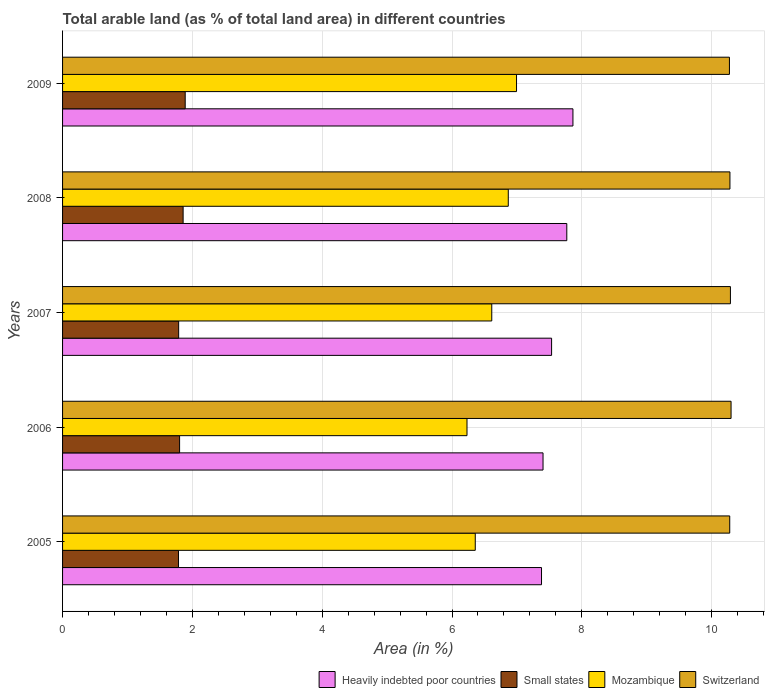How many groups of bars are there?
Your answer should be compact. 5. How many bars are there on the 1st tick from the top?
Your response must be concise. 4. What is the label of the 5th group of bars from the top?
Offer a very short reply. 2005. What is the percentage of arable land in Switzerland in 2009?
Ensure brevity in your answer.  10.27. Across all years, what is the maximum percentage of arable land in Heavily indebted poor countries?
Ensure brevity in your answer.  7.86. Across all years, what is the minimum percentage of arable land in Switzerland?
Give a very brief answer. 10.27. In which year was the percentage of arable land in Switzerland minimum?
Give a very brief answer. 2009. What is the total percentage of arable land in Mozambique in the graph?
Give a very brief answer. 33.06. What is the difference between the percentage of arable land in Switzerland in 2005 and that in 2007?
Offer a very short reply. -0.01. What is the difference between the percentage of arable land in Heavily indebted poor countries in 2009 and the percentage of arable land in Small states in 2008?
Give a very brief answer. 6.01. What is the average percentage of arable land in Mozambique per year?
Keep it short and to the point. 6.61. In the year 2005, what is the difference between the percentage of arable land in Heavily indebted poor countries and percentage of arable land in Small states?
Provide a succinct answer. 5.59. What is the ratio of the percentage of arable land in Heavily indebted poor countries in 2006 to that in 2008?
Make the answer very short. 0.95. Is the percentage of arable land in Mozambique in 2005 less than that in 2007?
Your response must be concise. Yes. What is the difference between the highest and the second highest percentage of arable land in Switzerland?
Offer a very short reply. 0.01. What is the difference between the highest and the lowest percentage of arable land in Heavily indebted poor countries?
Offer a terse response. 0.48. In how many years, is the percentage of arable land in Small states greater than the average percentage of arable land in Small states taken over all years?
Ensure brevity in your answer.  2. Is the sum of the percentage of arable land in Mozambique in 2005 and 2006 greater than the maximum percentage of arable land in Small states across all years?
Your response must be concise. Yes. Is it the case that in every year, the sum of the percentage of arable land in Mozambique and percentage of arable land in Heavily indebted poor countries is greater than the sum of percentage of arable land in Small states and percentage of arable land in Switzerland?
Make the answer very short. Yes. What does the 4th bar from the top in 2009 represents?
Ensure brevity in your answer.  Heavily indebted poor countries. What does the 4th bar from the bottom in 2007 represents?
Give a very brief answer. Switzerland. Is it the case that in every year, the sum of the percentage of arable land in Small states and percentage of arable land in Heavily indebted poor countries is greater than the percentage of arable land in Switzerland?
Offer a terse response. No. Are all the bars in the graph horizontal?
Offer a terse response. Yes. How many years are there in the graph?
Give a very brief answer. 5. Are the values on the major ticks of X-axis written in scientific E-notation?
Offer a terse response. No. Does the graph contain any zero values?
Make the answer very short. No. Does the graph contain grids?
Offer a very short reply. Yes. Where does the legend appear in the graph?
Give a very brief answer. Bottom right. How many legend labels are there?
Keep it short and to the point. 4. What is the title of the graph?
Keep it short and to the point. Total arable land (as % of total land area) in different countries. What is the label or title of the X-axis?
Ensure brevity in your answer.  Area (in %). What is the label or title of the Y-axis?
Provide a succinct answer. Years. What is the Area (in %) of Heavily indebted poor countries in 2005?
Provide a succinct answer. 7.38. What is the Area (in %) in Small states in 2005?
Make the answer very short. 1.79. What is the Area (in %) in Mozambique in 2005?
Provide a short and direct response. 6.36. What is the Area (in %) of Switzerland in 2005?
Provide a short and direct response. 10.28. What is the Area (in %) of Heavily indebted poor countries in 2006?
Keep it short and to the point. 7.4. What is the Area (in %) in Small states in 2006?
Make the answer very short. 1.8. What is the Area (in %) in Mozambique in 2006?
Provide a succinct answer. 6.23. What is the Area (in %) of Switzerland in 2006?
Your answer should be compact. 10.3. What is the Area (in %) of Heavily indebted poor countries in 2007?
Your answer should be compact. 7.53. What is the Area (in %) in Small states in 2007?
Ensure brevity in your answer.  1.79. What is the Area (in %) in Mozambique in 2007?
Make the answer very short. 6.61. What is the Area (in %) of Switzerland in 2007?
Offer a very short reply. 10.29. What is the Area (in %) in Heavily indebted poor countries in 2008?
Offer a very short reply. 7.77. What is the Area (in %) in Small states in 2008?
Your answer should be compact. 1.86. What is the Area (in %) of Mozambique in 2008?
Offer a very short reply. 6.87. What is the Area (in %) in Switzerland in 2008?
Offer a terse response. 10.28. What is the Area (in %) of Heavily indebted poor countries in 2009?
Your answer should be compact. 7.86. What is the Area (in %) in Small states in 2009?
Make the answer very short. 1.89. What is the Area (in %) in Mozambique in 2009?
Ensure brevity in your answer.  6.99. What is the Area (in %) of Switzerland in 2009?
Your answer should be very brief. 10.27. Across all years, what is the maximum Area (in %) of Heavily indebted poor countries?
Make the answer very short. 7.86. Across all years, what is the maximum Area (in %) of Small states?
Provide a succinct answer. 1.89. Across all years, what is the maximum Area (in %) in Mozambique?
Offer a terse response. 6.99. Across all years, what is the maximum Area (in %) of Switzerland?
Your answer should be very brief. 10.3. Across all years, what is the minimum Area (in %) of Heavily indebted poor countries?
Provide a short and direct response. 7.38. Across all years, what is the minimum Area (in %) of Small states?
Keep it short and to the point. 1.79. Across all years, what is the minimum Area (in %) in Mozambique?
Provide a succinct answer. 6.23. Across all years, what is the minimum Area (in %) in Switzerland?
Provide a short and direct response. 10.27. What is the total Area (in %) in Heavily indebted poor countries in the graph?
Provide a short and direct response. 37.95. What is the total Area (in %) of Small states in the graph?
Your answer should be very brief. 9.12. What is the total Area (in %) in Mozambique in the graph?
Keep it short and to the point. 33.06. What is the total Area (in %) of Switzerland in the graph?
Give a very brief answer. 51.42. What is the difference between the Area (in %) of Heavily indebted poor countries in 2005 and that in 2006?
Offer a terse response. -0.02. What is the difference between the Area (in %) of Small states in 2005 and that in 2006?
Keep it short and to the point. -0.02. What is the difference between the Area (in %) in Mozambique in 2005 and that in 2006?
Offer a terse response. 0.13. What is the difference between the Area (in %) in Switzerland in 2005 and that in 2006?
Your answer should be compact. -0.02. What is the difference between the Area (in %) of Heavily indebted poor countries in 2005 and that in 2007?
Offer a terse response. -0.16. What is the difference between the Area (in %) in Small states in 2005 and that in 2007?
Provide a short and direct response. -0. What is the difference between the Area (in %) in Mozambique in 2005 and that in 2007?
Provide a succinct answer. -0.25. What is the difference between the Area (in %) of Switzerland in 2005 and that in 2007?
Offer a very short reply. -0.01. What is the difference between the Area (in %) of Heavily indebted poor countries in 2005 and that in 2008?
Make the answer very short. -0.39. What is the difference between the Area (in %) of Small states in 2005 and that in 2008?
Your answer should be compact. -0.07. What is the difference between the Area (in %) of Mozambique in 2005 and that in 2008?
Offer a very short reply. -0.51. What is the difference between the Area (in %) in Switzerland in 2005 and that in 2008?
Provide a succinct answer. -0. What is the difference between the Area (in %) in Heavily indebted poor countries in 2005 and that in 2009?
Give a very brief answer. -0.48. What is the difference between the Area (in %) of Small states in 2005 and that in 2009?
Offer a very short reply. -0.1. What is the difference between the Area (in %) of Mozambique in 2005 and that in 2009?
Ensure brevity in your answer.  -0.64. What is the difference between the Area (in %) in Switzerland in 2005 and that in 2009?
Make the answer very short. 0. What is the difference between the Area (in %) of Heavily indebted poor countries in 2006 and that in 2007?
Your answer should be very brief. -0.13. What is the difference between the Area (in %) of Small states in 2006 and that in 2007?
Give a very brief answer. 0.01. What is the difference between the Area (in %) in Mozambique in 2006 and that in 2007?
Make the answer very short. -0.38. What is the difference between the Area (in %) of Switzerland in 2006 and that in 2007?
Give a very brief answer. 0.01. What is the difference between the Area (in %) in Heavily indebted poor countries in 2006 and that in 2008?
Your answer should be compact. -0.37. What is the difference between the Area (in %) in Small states in 2006 and that in 2008?
Give a very brief answer. -0.05. What is the difference between the Area (in %) of Mozambique in 2006 and that in 2008?
Make the answer very short. -0.64. What is the difference between the Area (in %) in Switzerland in 2006 and that in 2008?
Make the answer very short. 0.02. What is the difference between the Area (in %) of Heavily indebted poor countries in 2006 and that in 2009?
Offer a terse response. -0.46. What is the difference between the Area (in %) of Small states in 2006 and that in 2009?
Offer a terse response. -0.09. What is the difference between the Area (in %) of Mozambique in 2006 and that in 2009?
Your answer should be compact. -0.76. What is the difference between the Area (in %) in Switzerland in 2006 and that in 2009?
Offer a terse response. 0.03. What is the difference between the Area (in %) in Heavily indebted poor countries in 2007 and that in 2008?
Your answer should be compact. -0.23. What is the difference between the Area (in %) in Small states in 2007 and that in 2008?
Your response must be concise. -0.07. What is the difference between the Area (in %) in Mozambique in 2007 and that in 2008?
Your response must be concise. -0.25. What is the difference between the Area (in %) of Switzerland in 2007 and that in 2008?
Ensure brevity in your answer.  0.01. What is the difference between the Area (in %) of Heavily indebted poor countries in 2007 and that in 2009?
Provide a short and direct response. -0.33. What is the difference between the Area (in %) of Small states in 2007 and that in 2009?
Provide a succinct answer. -0.1. What is the difference between the Area (in %) of Mozambique in 2007 and that in 2009?
Your answer should be compact. -0.38. What is the difference between the Area (in %) of Switzerland in 2007 and that in 2009?
Your response must be concise. 0.02. What is the difference between the Area (in %) in Heavily indebted poor countries in 2008 and that in 2009?
Offer a terse response. -0.09. What is the difference between the Area (in %) of Small states in 2008 and that in 2009?
Ensure brevity in your answer.  -0.03. What is the difference between the Area (in %) of Mozambique in 2008 and that in 2009?
Ensure brevity in your answer.  -0.13. What is the difference between the Area (in %) in Switzerland in 2008 and that in 2009?
Provide a succinct answer. 0.01. What is the difference between the Area (in %) in Heavily indebted poor countries in 2005 and the Area (in %) in Small states in 2006?
Give a very brief answer. 5.58. What is the difference between the Area (in %) of Heavily indebted poor countries in 2005 and the Area (in %) of Mozambique in 2006?
Ensure brevity in your answer.  1.15. What is the difference between the Area (in %) of Heavily indebted poor countries in 2005 and the Area (in %) of Switzerland in 2006?
Provide a succinct answer. -2.92. What is the difference between the Area (in %) of Small states in 2005 and the Area (in %) of Mozambique in 2006?
Make the answer very short. -4.45. What is the difference between the Area (in %) of Small states in 2005 and the Area (in %) of Switzerland in 2006?
Provide a succinct answer. -8.51. What is the difference between the Area (in %) of Mozambique in 2005 and the Area (in %) of Switzerland in 2006?
Your answer should be very brief. -3.94. What is the difference between the Area (in %) of Heavily indebted poor countries in 2005 and the Area (in %) of Small states in 2007?
Make the answer very short. 5.59. What is the difference between the Area (in %) of Heavily indebted poor countries in 2005 and the Area (in %) of Mozambique in 2007?
Provide a succinct answer. 0.77. What is the difference between the Area (in %) in Heavily indebted poor countries in 2005 and the Area (in %) in Switzerland in 2007?
Your answer should be compact. -2.91. What is the difference between the Area (in %) in Small states in 2005 and the Area (in %) in Mozambique in 2007?
Provide a short and direct response. -4.83. What is the difference between the Area (in %) in Small states in 2005 and the Area (in %) in Switzerland in 2007?
Make the answer very short. -8.5. What is the difference between the Area (in %) in Mozambique in 2005 and the Area (in %) in Switzerland in 2007?
Make the answer very short. -3.93. What is the difference between the Area (in %) of Heavily indebted poor countries in 2005 and the Area (in %) of Small states in 2008?
Your answer should be very brief. 5.52. What is the difference between the Area (in %) in Heavily indebted poor countries in 2005 and the Area (in %) in Mozambique in 2008?
Provide a short and direct response. 0.51. What is the difference between the Area (in %) of Heavily indebted poor countries in 2005 and the Area (in %) of Switzerland in 2008?
Provide a succinct answer. -2.9. What is the difference between the Area (in %) of Small states in 2005 and the Area (in %) of Mozambique in 2008?
Keep it short and to the point. -5.08. What is the difference between the Area (in %) of Small states in 2005 and the Area (in %) of Switzerland in 2008?
Provide a short and direct response. -8.5. What is the difference between the Area (in %) of Mozambique in 2005 and the Area (in %) of Switzerland in 2008?
Provide a succinct answer. -3.92. What is the difference between the Area (in %) in Heavily indebted poor countries in 2005 and the Area (in %) in Small states in 2009?
Give a very brief answer. 5.49. What is the difference between the Area (in %) in Heavily indebted poor countries in 2005 and the Area (in %) in Mozambique in 2009?
Give a very brief answer. 0.39. What is the difference between the Area (in %) of Heavily indebted poor countries in 2005 and the Area (in %) of Switzerland in 2009?
Make the answer very short. -2.9. What is the difference between the Area (in %) in Small states in 2005 and the Area (in %) in Mozambique in 2009?
Your answer should be compact. -5.21. What is the difference between the Area (in %) in Small states in 2005 and the Area (in %) in Switzerland in 2009?
Your answer should be compact. -8.49. What is the difference between the Area (in %) of Mozambique in 2005 and the Area (in %) of Switzerland in 2009?
Give a very brief answer. -3.92. What is the difference between the Area (in %) of Heavily indebted poor countries in 2006 and the Area (in %) of Small states in 2007?
Provide a short and direct response. 5.61. What is the difference between the Area (in %) of Heavily indebted poor countries in 2006 and the Area (in %) of Mozambique in 2007?
Make the answer very short. 0.79. What is the difference between the Area (in %) in Heavily indebted poor countries in 2006 and the Area (in %) in Switzerland in 2007?
Give a very brief answer. -2.89. What is the difference between the Area (in %) of Small states in 2006 and the Area (in %) of Mozambique in 2007?
Offer a terse response. -4.81. What is the difference between the Area (in %) of Small states in 2006 and the Area (in %) of Switzerland in 2007?
Make the answer very short. -8.49. What is the difference between the Area (in %) in Mozambique in 2006 and the Area (in %) in Switzerland in 2007?
Provide a short and direct response. -4.06. What is the difference between the Area (in %) in Heavily indebted poor countries in 2006 and the Area (in %) in Small states in 2008?
Provide a short and direct response. 5.55. What is the difference between the Area (in %) of Heavily indebted poor countries in 2006 and the Area (in %) of Mozambique in 2008?
Your answer should be compact. 0.54. What is the difference between the Area (in %) in Heavily indebted poor countries in 2006 and the Area (in %) in Switzerland in 2008?
Ensure brevity in your answer.  -2.88. What is the difference between the Area (in %) in Small states in 2006 and the Area (in %) in Mozambique in 2008?
Make the answer very short. -5.06. What is the difference between the Area (in %) of Small states in 2006 and the Area (in %) of Switzerland in 2008?
Keep it short and to the point. -8.48. What is the difference between the Area (in %) of Mozambique in 2006 and the Area (in %) of Switzerland in 2008?
Your answer should be compact. -4.05. What is the difference between the Area (in %) of Heavily indebted poor countries in 2006 and the Area (in %) of Small states in 2009?
Provide a short and direct response. 5.51. What is the difference between the Area (in %) of Heavily indebted poor countries in 2006 and the Area (in %) of Mozambique in 2009?
Give a very brief answer. 0.41. What is the difference between the Area (in %) of Heavily indebted poor countries in 2006 and the Area (in %) of Switzerland in 2009?
Offer a very short reply. -2.87. What is the difference between the Area (in %) in Small states in 2006 and the Area (in %) in Mozambique in 2009?
Your answer should be very brief. -5.19. What is the difference between the Area (in %) in Small states in 2006 and the Area (in %) in Switzerland in 2009?
Your response must be concise. -8.47. What is the difference between the Area (in %) in Mozambique in 2006 and the Area (in %) in Switzerland in 2009?
Your answer should be very brief. -4.04. What is the difference between the Area (in %) of Heavily indebted poor countries in 2007 and the Area (in %) of Small states in 2008?
Give a very brief answer. 5.68. What is the difference between the Area (in %) in Heavily indebted poor countries in 2007 and the Area (in %) in Mozambique in 2008?
Your answer should be compact. 0.67. What is the difference between the Area (in %) of Heavily indebted poor countries in 2007 and the Area (in %) of Switzerland in 2008?
Ensure brevity in your answer.  -2.75. What is the difference between the Area (in %) of Small states in 2007 and the Area (in %) of Mozambique in 2008?
Give a very brief answer. -5.08. What is the difference between the Area (in %) in Small states in 2007 and the Area (in %) in Switzerland in 2008?
Your response must be concise. -8.49. What is the difference between the Area (in %) of Mozambique in 2007 and the Area (in %) of Switzerland in 2008?
Offer a terse response. -3.67. What is the difference between the Area (in %) in Heavily indebted poor countries in 2007 and the Area (in %) in Small states in 2009?
Your answer should be compact. 5.64. What is the difference between the Area (in %) in Heavily indebted poor countries in 2007 and the Area (in %) in Mozambique in 2009?
Ensure brevity in your answer.  0.54. What is the difference between the Area (in %) in Heavily indebted poor countries in 2007 and the Area (in %) in Switzerland in 2009?
Make the answer very short. -2.74. What is the difference between the Area (in %) of Small states in 2007 and the Area (in %) of Mozambique in 2009?
Keep it short and to the point. -5.21. What is the difference between the Area (in %) in Small states in 2007 and the Area (in %) in Switzerland in 2009?
Provide a short and direct response. -8.49. What is the difference between the Area (in %) in Mozambique in 2007 and the Area (in %) in Switzerland in 2009?
Give a very brief answer. -3.66. What is the difference between the Area (in %) in Heavily indebted poor countries in 2008 and the Area (in %) in Small states in 2009?
Your answer should be compact. 5.88. What is the difference between the Area (in %) of Heavily indebted poor countries in 2008 and the Area (in %) of Mozambique in 2009?
Give a very brief answer. 0.77. What is the difference between the Area (in %) in Heavily indebted poor countries in 2008 and the Area (in %) in Switzerland in 2009?
Your answer should be compact. -2.51. What is the difference between the Area (in %) of Small states in 2008 and the Area (in %) of Mozambique in 2009?
Offer a very short reply. -5.14. What is the difference between the Area (in %) in Small states in 2008 and the Area (in %) in Switzerland in 2009?
Provide a succinct answer. -8.42. What is the difference between the Area (in %) of Mozambique in 2008 and the Area (in %) of Switzerland in 2009?
Your answer should be compact. -3.41. What is the average Area (in %) in Heavily indebted poor countries per year?
Your answer should be very brief. 7.59. What is the average Area (in %) of Small states per year?
Provide a succinct answer. 1.82. What is the average Area (in %) of Mozambique per year?
Your answer should be very brief. 6.61. What is the average Area (in %) of Switzerland per year?
Offer a terse response. 10.28. In the year 2005, what is the difference between the Area (in %) of Heavily indebted poor countries and Area (in %) of Small states?
Give a very brief answer. 5.59. In the year 2005, what is the difference between the Area (in %) of Heavily indebted poor countries and Area (in %) of Mozambique?
Offer a terse response. 1.02. In the year 2005, what is the difference between the Area (in %) of Heavily indebted poor countries and Area (in %) of Switzerland?
Your response must be concise. -2.9. In the year 2005, what is the difference between the Area (in %) in Small states and Area (in %) in Mozambique?
Make the answer very short. -4.57. In the year 2005, what is the difference between the Area (in %) in Small states and Area (in %) in Switzerland?
Provide a succinct answer. -8.49. In the year 2005, what is the difference between the Area (in %) in Mozambique and Area (in %) in Switzerland?
Provide a short and direct response. -3.92. In the year 2006, what is the difference between the Area (in %) of Heavily indebted poor countries and Area (in %) of Small states?
Keep it short and to the point. 5.6. In the year 2006, what is the difference between the Area (in %) of Heavily indebted poor countries and Area (in %) of Mozambique?
Keep it short and to the point. 1.17. In the year 2006, what is the difference between the Area (in %) in Heavily indebted poor countries and Area (in %) in Switzerland?
Offer a very short reply. -2.9. In the year 2006, what is the difference between the Area (in %) in Small states and Area (in %) in Mozambique?
Your response must be concise. -4.43. In the year 2006, what is the difference between the Area (in %) in Small states and Area (in %) in Switzerland?
Give a very brief answer. -8.5. In the year 2006, what is the difference between the Area (in %) in Mozambique and Area (in %) in Switzerland?
Keep it short and to the point. -4.07. In the year 2007, what is the difference between the Area (in %) of Heavily indebted poor countries and Area (in %) of Small states?
Provide a succinct answer. 5.75. In the year 2007, what is the difference between the Area (in %) in Heavily indebted poor countries and Area (in %) in Mozambique?
Provide a succinct answer. 0.92. In the year 2007, what is the difference between the Area (in %) in Heavily indebted poor countries and Area (in %) in Switzerland?
Your answer should be very brief. -2.76. In the year 2007, what is the difference between the Area (in %) in Small states and Area (in %) in Mozambique?
Make the answer very short. -4.82. In the year 2007, what is the difference between the Area (in %) in Small states and Area (in %) in Switzerland?
Make the answer very short. -8.5. In the year 2007, what is the difference between the Area (in %) in Mozambique and Area (in %) in Switzerland?
Your answer should be very brief. -3.68. In the year 2008, what is the difference between the Area (in %) in Heavily indebted poor countries and Area (in %) in Small states?
Give a very brief answer. 5.91. In the year 2008, what is the difference between the Area (in %) of Heavily indebted poor countries and Area (in %) of Mozambique?
Keep it short and to the point. 0.9. In the year 2008, what is the difference between the Area (in %) of Heavily indebted poor countries and Area (in %) of Switzerland?
Give a very brief answer. -2.51. In the year 2008, what is the difference between the Area (in %) in Small states and Area (in %) in Mozambique?
Offer a terse response. -5.01. In the year 2008, what is the difference between the Area (in %) of Small states and Area (in %) of Switzerland?
Provide a succinct answer. -8.42. In the year 2008, what is the difference between the Area (in %) of Mozambique and Area (in %) of Switzerland?
Your answer should be compact. -3.42. In the year 2009, what is the difference between the Area (in %) of Heavily indebted poor countries and Area (in %) of Small states?
Offer a very short reply. 5.97. In the year 2009, what is the difference between the Area (in %) in Heavily indebted poor countries and Area (in %) in Mozambique?
Provide a succinct answer. 0.87. In the year 2009, what is the difference between the Area (in %) in Heavily indebted poor countries and Area (in %) in Switzerland?
Provide a succinct answer. -2.41. In the year 2009, what is the difference between the Area (in %) in Small states and Area (in %) in Mozambique?
Provide a succinct answer. -5.1. In the year 2009, what is the difference between the Area (in %) in Small states and Area (in %) in Switzerland?
Offer a very short reply. -8.38. In the year 2009, what is the difference between the Area (in %) of Mozambique and Area (in %) of Switzerland?
Your answer should be very brief. -3.28. What is the ratio of the Area (in %) in Small states in 2005 to that in 2006?
Your answer should be compact. 0.99. What is the ratio of the Area (in %) of Mozambique in 2005 to that in 2006?
Keep it short and to the point. 1.02. What is the ratio of the Area (in %) in Switzerland in 2005 to that in 2006?
Offer a terse response. 1. What is the ratio of the Area (in %) in Heavily indebted poor countries in 2005 to that in 2007?
Your response must be concise. 0.98. What is the ratio of the Area (in %) of Mozambique in 2005 to that in 2007?
Your answer should be compact. 0.96. What is the ratio of the Area (in %) in Heavily indebted poor countries in 2005 to that in 2008?
Offer a very short reply. 0.95. What is the ratio of the Area (in %) of Small states in 2005 to that in 2008?
Ensure brevity in your answer.  0.96. What is the ratio of the Area (in %) in Mozambique in 2005 to that in 2008?
Ensure brevity in your answer.  0.93. What is the ratio of the Area (in %) in Heavily indebted poor countries in 2005 to that in 2009?
Your answer should be compact. 0.94. What is the ratio of the Area (in %) of Small states in 2005 to that in 2009?
Keep it short and to the point. 0.95. What is the ratio of the Area (in %) of Heavily indebted poor countries in 2006 to that in 2007?
Make the answer very short. 0.98. What is the ratio of the Area (in %) in Small states in 2006 to that in 2007?
Provide a succinct answer. 1.01. What is the ratio of the Area (in %) in Mozambique in 2006 to that in 2007?
Your answer should be very brief. 0.94. What is the ratio of the Area (in %) of Switzerland in 2006 to that in 2007?
Provide a short and direct response. 1. What is the ratio of the Area (in %) in Heavily indebted poor countries in 2006 to that in 2008?
Offer a very short reply. 0.95. What is the ratio of the Area (in %) of Small states in 2006 to that in 2008?
Provide a succinct answer. 0.97. What is the ratio of the Area (in %) in Mozambique in 2006 to that in 2008?
Your answer should be compact. 0.91. What is the ratio of the Area (in %) in Heavily indebted poor countries in 2006 to that in 2009?
Provide a short and direct response. 0.94. What is the ratio of the Area (in %) of Small states in 2006 to that in 2009?
Your answer should be compact. 0.95. What is the ratio of the Area (in %) of Mozambique in 2006 to that in 2009?
Your answer should be very brief. 0.89. What is the ratio of the Area (in %) of Switzerland in 2006 to that in 2009?
Give a very brief answer. 1. What is the ratio of the Area (in %) of Heavily indebted poor countries in 2007 to that in 2008?
Your response must be concise. 0.97. What is the ratio of the Area (in %) in Small states in 2007 to that in 2008?
Offer a very short reply. 0.96. What is the ratio of the Area (in %) of Switzerland in 2007 to that in 2008?
Offer a terse response. 1. What is the ratio of the Area (in %) of Heavily indebted poor countries in 2007 to that in 2009?
Provide a short and direct response. 0.96. What is the ratio of the Area (in %) of Small states in 2007 to that in 2009?
Offer a terse response. 0.95. What is the ratio of the Area (in %) of Mozambique in 2007 to that in 2009?
Your response must be concise. 0.95. What is the ratio of the Area (in %) in Small states in 2008 to that in 2009?
Ensure brevity in your answer.  0.98. What is the ratio of the Area (in %) in Mozambique in 2008 to that in 2009?
Keep it short and to the point. 0.98. What is the ratio of the Area (in %) of Switzerland in 2008 to that in 2009?
Provide a short and direct response. 1. What is the difference between the highest and the second highest Area (in %) in Heavily indebted poor countries?
Provide a succinct answer. 0.09. What is the difference between the highest and the second highest Area (in %) in Small states?
Provide a succinct answer. 0.03. What is the difference between the highest and the second highest Area (in %) of Mozambique?
Make the answer very short. 0.13. What is the difference between the highest and the second highest Area (in %) of Switzerland?
Give a very brief answer. 0.01. What is the difference between the highest and the lowest Area (in %) of Heavily indebted poor countries?
Keep it short and to the point. 0.48. What is the difference between the highest and the lowest Area (in %) in Small states?
Offer a terse response. 0.1. What is the difference between the highest and the lowest Area (in %) of Mozambique?
Offer a terse response. 0.76. What is the difference between the highest and the lowest Area (in %) in Switzerland?
Give a very brief answer. 0.03. 